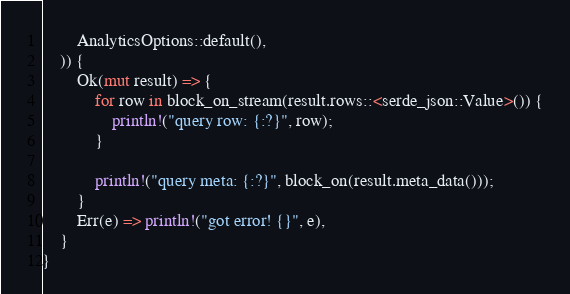<code> <loc_0><loc_0><loc_500><loc_500><_Rust_>        AnalyticsOptions::default(),
    )) {
        Ok(mut result) => {
            for row in block_on_stream(result.rows::<serde_json::Value>()) {
                println!("query row: {:?}", row);
            }

            println!("query meta: {:?}", block_on(result.meta_data()));
        }
        Err(e) => println!("got error! {}", e),
    }
}
</code> 